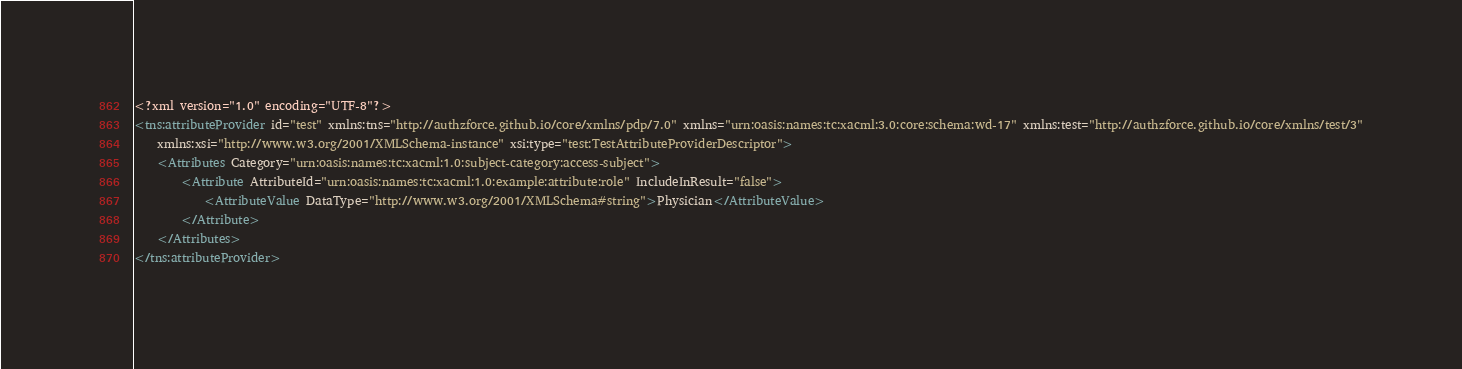<code> <loc_0><loc_0><loc_500><loc_500><_XML_><?xml version="1.0" encoding="UTF-8"?>
<tns:attributeProvider id="test" xmlns:tns="http://authzforce.github.io/core/xmlns/pdp/7.0" xmlns="urn:oasis:names:tc:xacml:3.0:core:schema:wd-17" xmlns:test="http://authzforce.github.io/core/xmlns/test/3"
	xmlns:xsi="http://www.w3.org/2001/XMLSchema-instance" xsi:type="test:TestAttributeProviderDescriptor">
	<Attributes Category="urn:oasis:names:tc:xacml:1.0:subject-category:access-subject">
		<Attribute AttributeId="urn:oasis:names:tc:xacml:1.0:example:attribute:role" IncludeInResult="false">
			<AttributeValue DataType="http://www.w3.org/2001/XMLSchema#string">Physician</AttributeValue>
		</Attribute>
	</Attributes>
</tns:attributeProvider>
</code> 